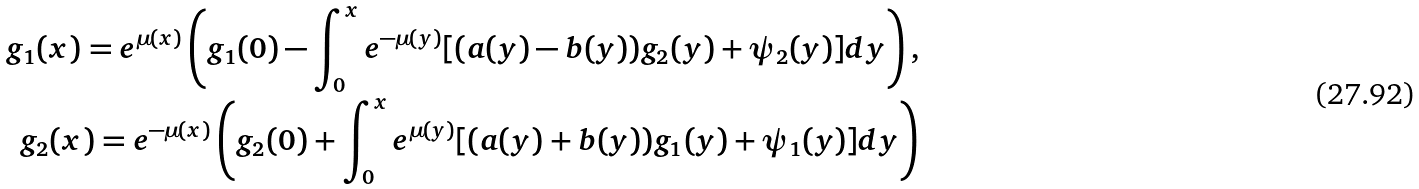Convert formula to latex. <formula><loc_0><loc_0><loc_500><loc_500>g _ { 1 } ( x ) = e ^ { \mu ( x ) } \left ( g _ { 1 } ( 0 ) - \int _ { 0 } ^ { x } e ^ { - \mu ( y ) } [ ( a ( y ) - b ( y ) ) g _ { 2 } ( y ) + \psi _ { 2 } ( y ) ] d y \right ) , \\ g _ { 2 } ( x ) = e ^ { - \mu ( x ) } \left ( g _ { 2 } ( 0 ) + \int _ { 0 } ^ { x } e ^ { \mu ( y ) } [ ( a ( y ) + b ( y ) ) g _ { 1 } ( y ) + \psi _ { 1 } ( y ) ] d y \right )</formula> 